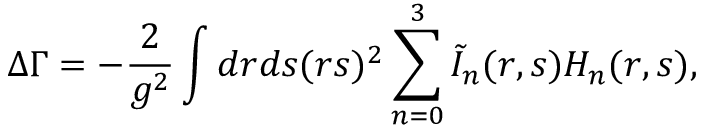Convert formula to latex. <formula><loc_0><loc_0><loc_500><loc_500>\Delta \Gamma = - \frac { 2 } { g ^ { 2 } } \int d r d s ( r s ) ^ { 2 } \sum _ { n = 0 } ^ { 3 } \tilde { I } _ { n } ( r , s ) H _ { n } ( r , s ) ,</formula> 